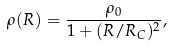<formula> <loc_0><loc_0><loc_500><loc_500>\rho ( R ) = \frac { \rho _ { 0 } } { 1 + ( { { R } / { R _ { C } } } ) ^ { 2 } } ,</formula> 